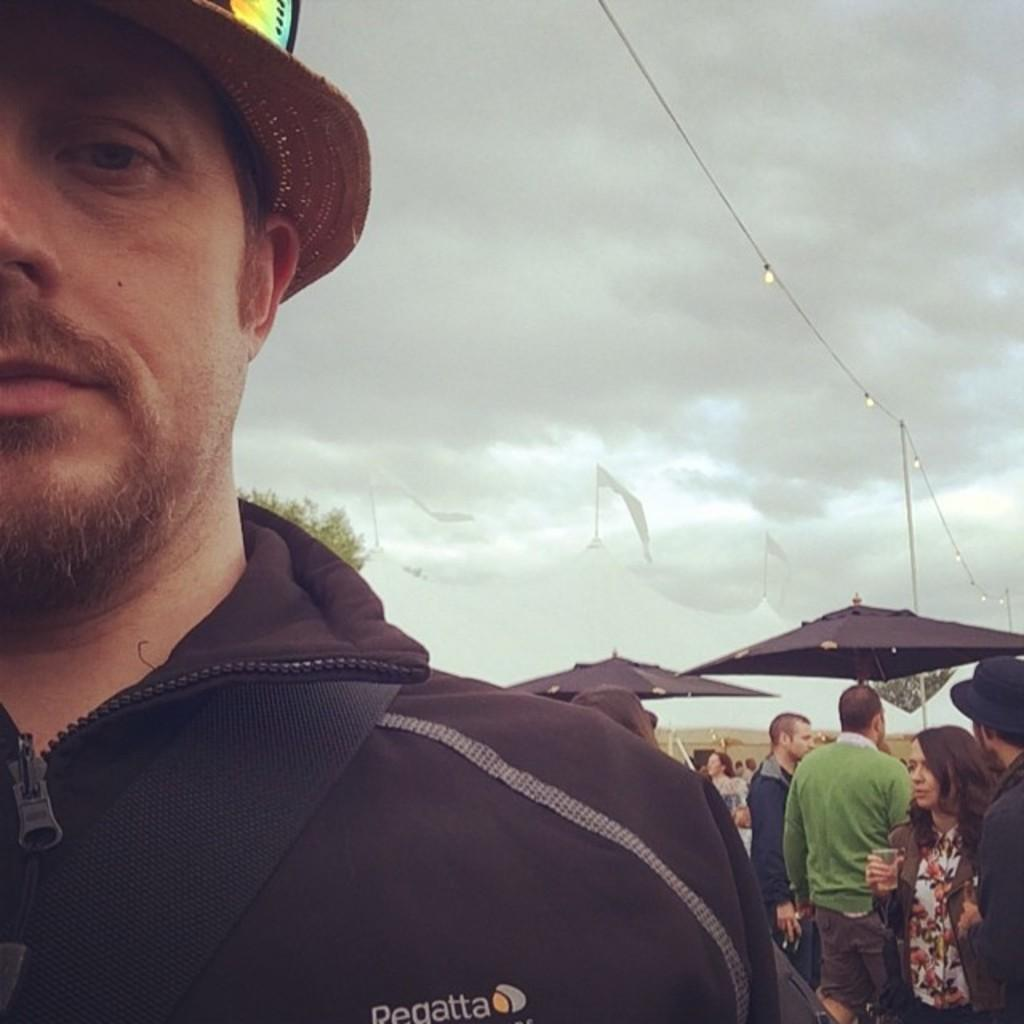What is the main subject of the image? There is a man standing in the image. Can you describe the man's appearance? The man is wearing a hat. How many people are present in the image? There are people standing in the image. What objects can be seen in the image besides the people? There are two black umbrellas in the image. What is visible at the top of the image? The sky is visible at the top of the image. How would you describe the weather based on the sky? The sky is cloudy, which suggests it might be overcast or about to rain. What type of stick can be seen in the man's hand in the image? There is no stick present in the man's hand or in the image. What kind of cork is used to hold the umbrellas in the image? There is no cork present in the image; the umbrellas are held by the people standing in the image. 